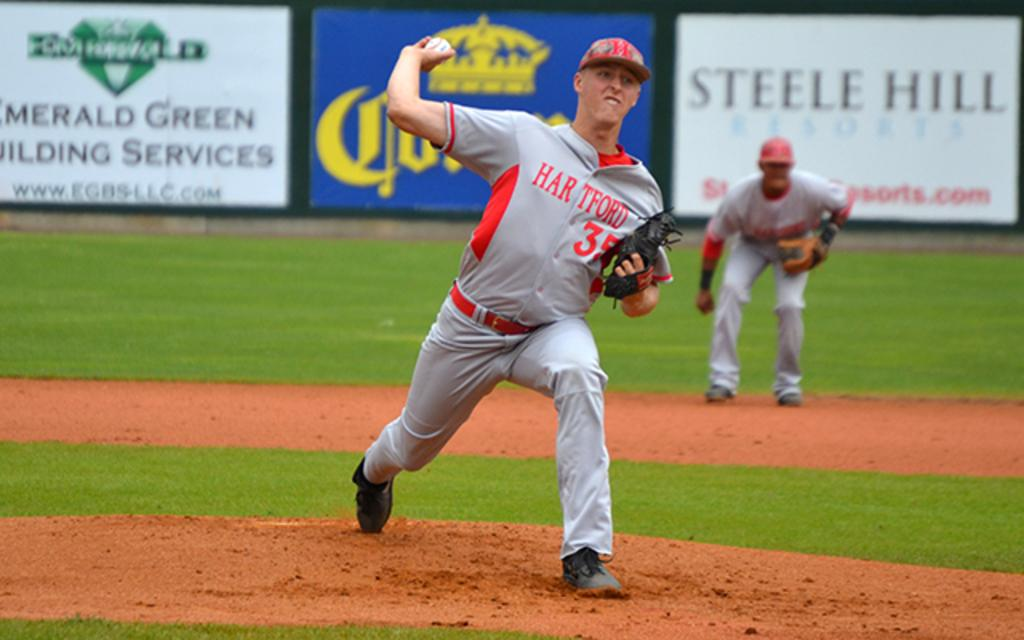<image>
Render a clear and concise summary of the photo. Baseball players on the field in front of a banner that has Steele Hill in black letters. 